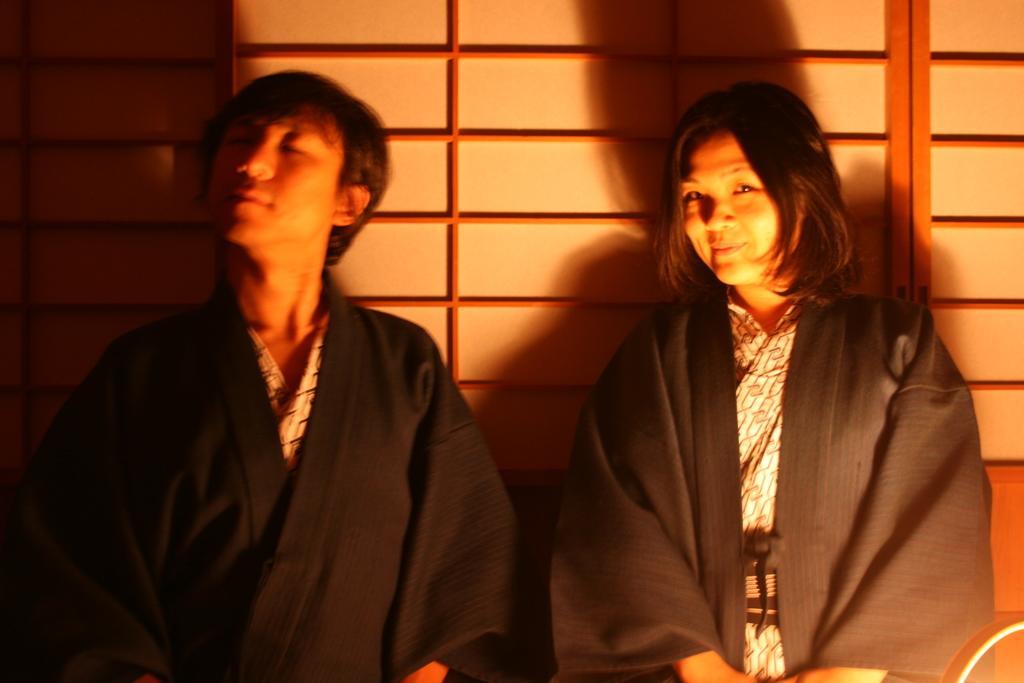How would you summarize this image in a sentence or two? In this image I can see two persons and I can see both of them are wearing black colour dress. On the right side I can see smile on her face. I can also see this image is little bit blurry. 